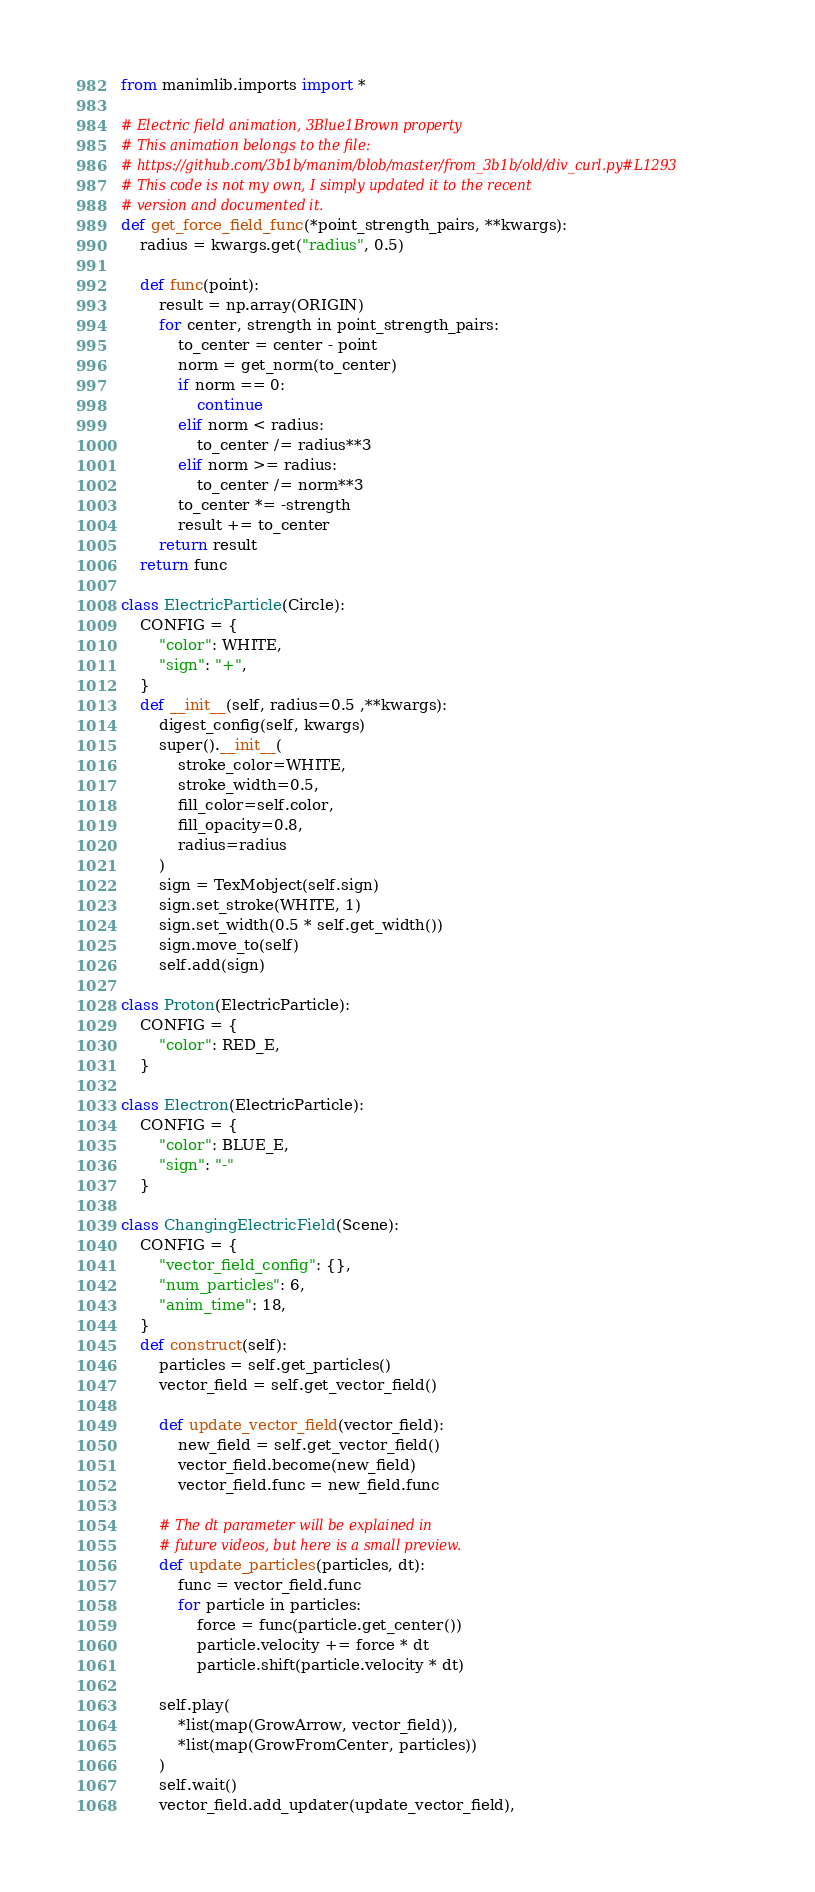Convert code to text. <code><loc_0><loc_0><loc_500><loc_500><_Python_>from manimlib.imports import *

# Electric field animation, 3Blue1Brown property
# This animation belongs to the file:
# https://github.com/3b1b/manim/blob/master/from_3b1b/old/div_curl.py#L1293
# This code is not my own, I simply updated it to the recent 
# version and documented it.
def get_force_field_func(*point_strength_pairs, **kwargs):
    radius = kwargs.get("radius", 0.5)

    def func(point):
        result = np.array(ORIGIN)
        for center, strength in point_strength_pairs:
            to_center = center - point
            norm = get_norm(to_center)
            if norm == 0:
                continue
            elif norm < radius:
                to_center /= radius**3
            elif norm >= radius:
                to_center /= norm**3
            to_center *= -strength
            result += to_center
        return result
    return func

class ElectricParticle(Circle):
    CONFIG = {
        "color": WHITE,
        "sign": "+",
    }
    def __init__(self, radius=0.5 ,**kwargs):
        digest_config(self, kwargs)
        super().__init__(
            stroke_color=WHITE,
            stroke_width=0.5,
            fill_color=self.color,
            fill_opacity=0.8,
            radius=radius
        )
        sign = TexMobject(self.sign)
        sign.set_stroke(WHITE, 1)
        sign.set_width(0.5 * self.get_width())
        sign.move_to(self)
        self.add(sign)

class Proton(ElectricParticle):
    CONFIG = {
        "color": RED_E,
    }

class Electron(ElectricParticle):
    CONFIG = {
        "color": BLUE_E,
        "sign": "-"
    }

class ChangingElectricField(Scene):
    CONFIG = {
        "vector_field_config": {},
        "num_particles": 6,
        "anim_time": 18,
    }
    def construct(self):
        particles = self.get_particles()
        vector_field = self.get_vector_field()

        def update_vector_field(vector_field):
            new_field = self.get_vector_field()
            vector_field.become(new_field)
            vector_field.func = new_field.func

        # The dt parameter will be explained in 
        # future videos, but here is a small preview.
        def update_particles(particles, dt):
            func = vector_field.func
            for particle in particles:
                force = func(particle.get_center())
                particle.velocity += force * dt
                particle.shift(particle.velocity * dt)

        self.play(
            *list(map(GrowArrow, vector_field)),
            *list(map(GrowFromCenter, particles))
        )
        self.wait()
        vector_field.add_updater(update_vector_field),</code> 